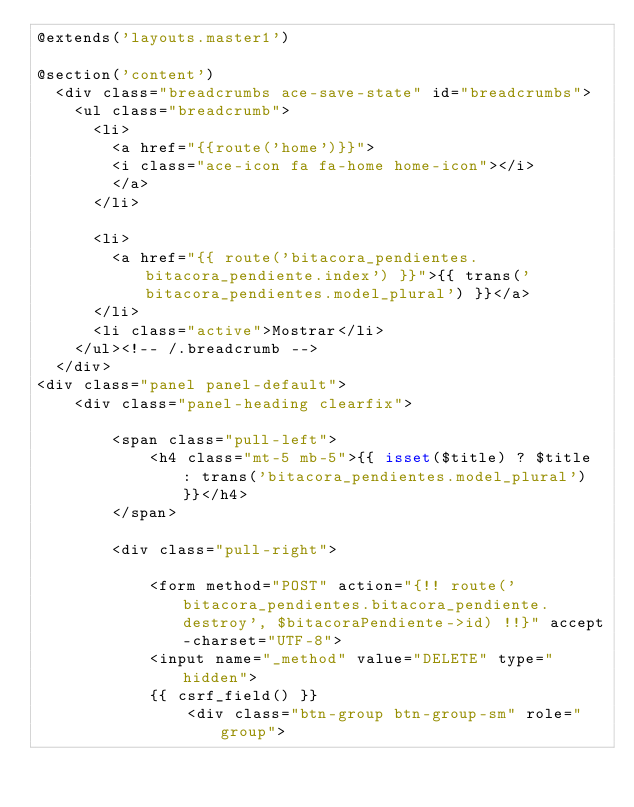<code> <loc_0><loc_0><loc_500><loc_500><_PHP_>@extends('layouts.master1')

@section('content')
	<div class="breadcrumbs ace-save-state" id="breadcrumbs">
		<ul class="breadcrumb">
			<li>
				<a href="{{route('home')}}">
				<i class="ace-icon fa fa-home home-icon"></i>
				</a>
			</li>

			<li>
				<a href="{{ route('bitacora_pendientes.bitacora_pendiente.index') }}">{{ trans('bitacora_pendientes.model_plural') }}</a>
			</li>
			<li class="active">Mostrar</li>
		</ul><!-- /.breadcrumb -->
	</div>
<div class="panel panel-default">
    <div class="panel-heading clearfix">

        <span class="pull-left">
            <h4 class="mt-5 mb-5">{{ isset($title) ? $title : trans('bitacora_pendientes.model_plural') }}</h4>
        </span>

        <div class="pull-right">

            <form method="POST" action="{!! route('bitacora_pendientes.bitacora_pendiente.destroy', $bitacoraPendiente->id) !!}" accept-charset="UTF-8">
            <input name="_method" value="DELETE" type="hidden">
            {{ csrf_field() }}
                <div class="btn-group btn-group-sm" role="group"></code> 